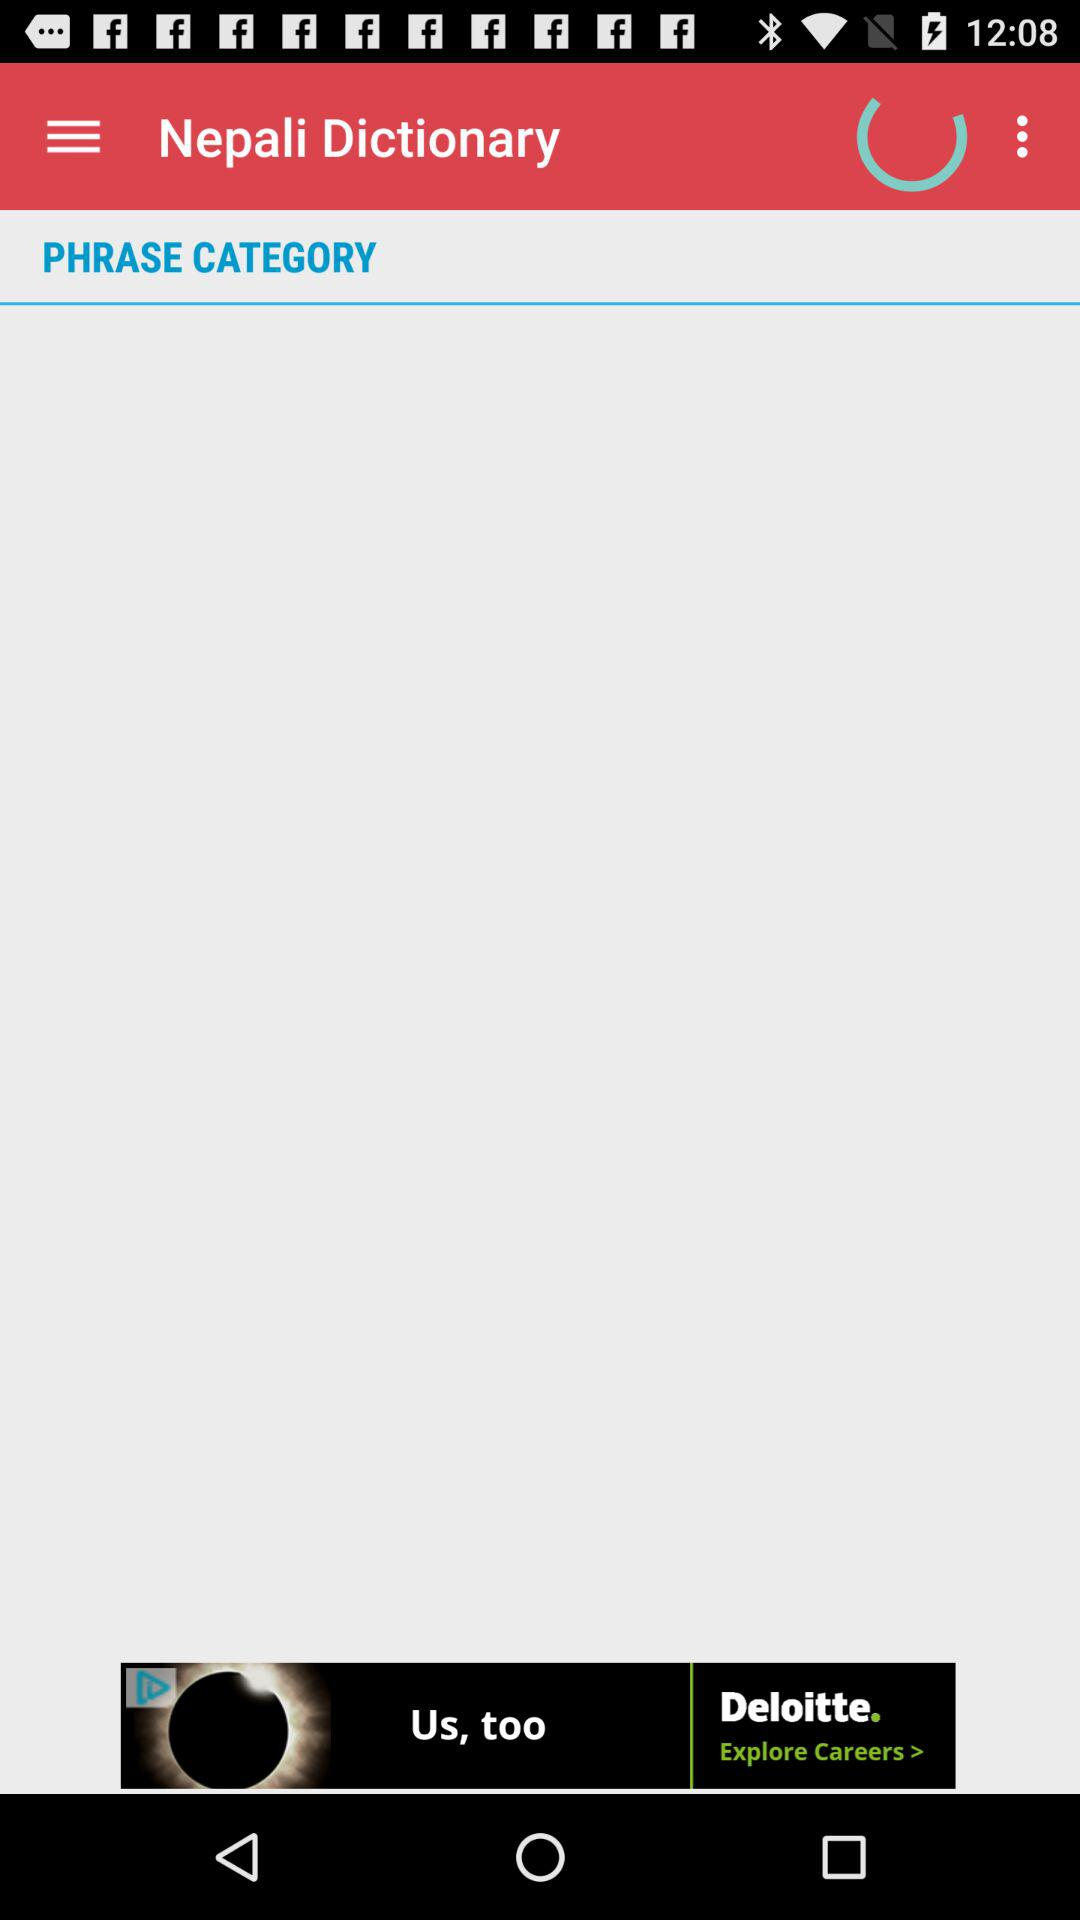What is the name of the application? The name of the application is "Nepali Dictionary". 